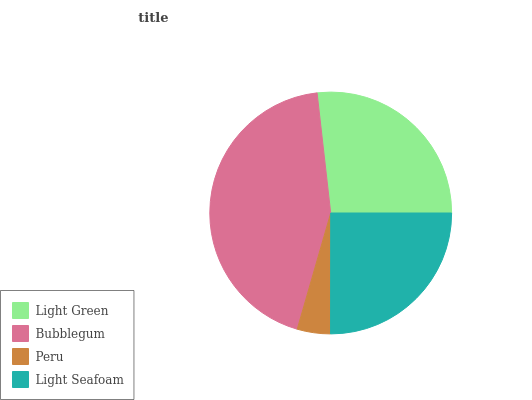Is Peru the minimum?
Answer yes or no. Yes. Is Bubblegum the maximum?
Answer yes or no. Yes. Is Bubblegum the minimum?
Answer yes or no. No. Is Peru the maximum?
Answer yes or no. No. Is Bubblegum greater than Peru?
Answer yes or no. Yes. Is Peru less than Bubblegum?
Answer yes or no. Yes. Is Peru greater than Bubblegum?
Answer yes or no. No. Is Bubblegum less than Peru?
Answer yes or no. No. Is Light Green the high median?
Answer yes or no. Yes. Is Light Seafoam the low median?
Answer yes or no. Yes. Is Light Seafoam the high median?
Answer yes or no. No. Is Peru the low median?
Answer yes or no. No. 